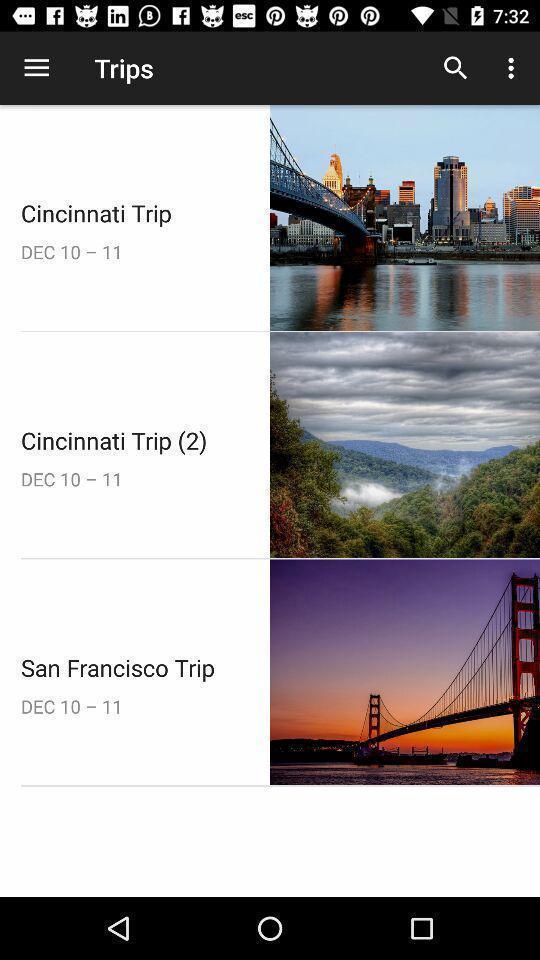Provide a description of this screenshot. Screen displaying the various cities for trip. 